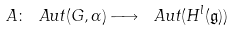Convert formula to latex. <formula><loc_0><loc_0><loc_500><loc_500>A \colon \ A u t ( G , \Gamma ) \longrightarrow \ A u t ( H ^ { l } ( \mathfrak { g } ) )</formula> 